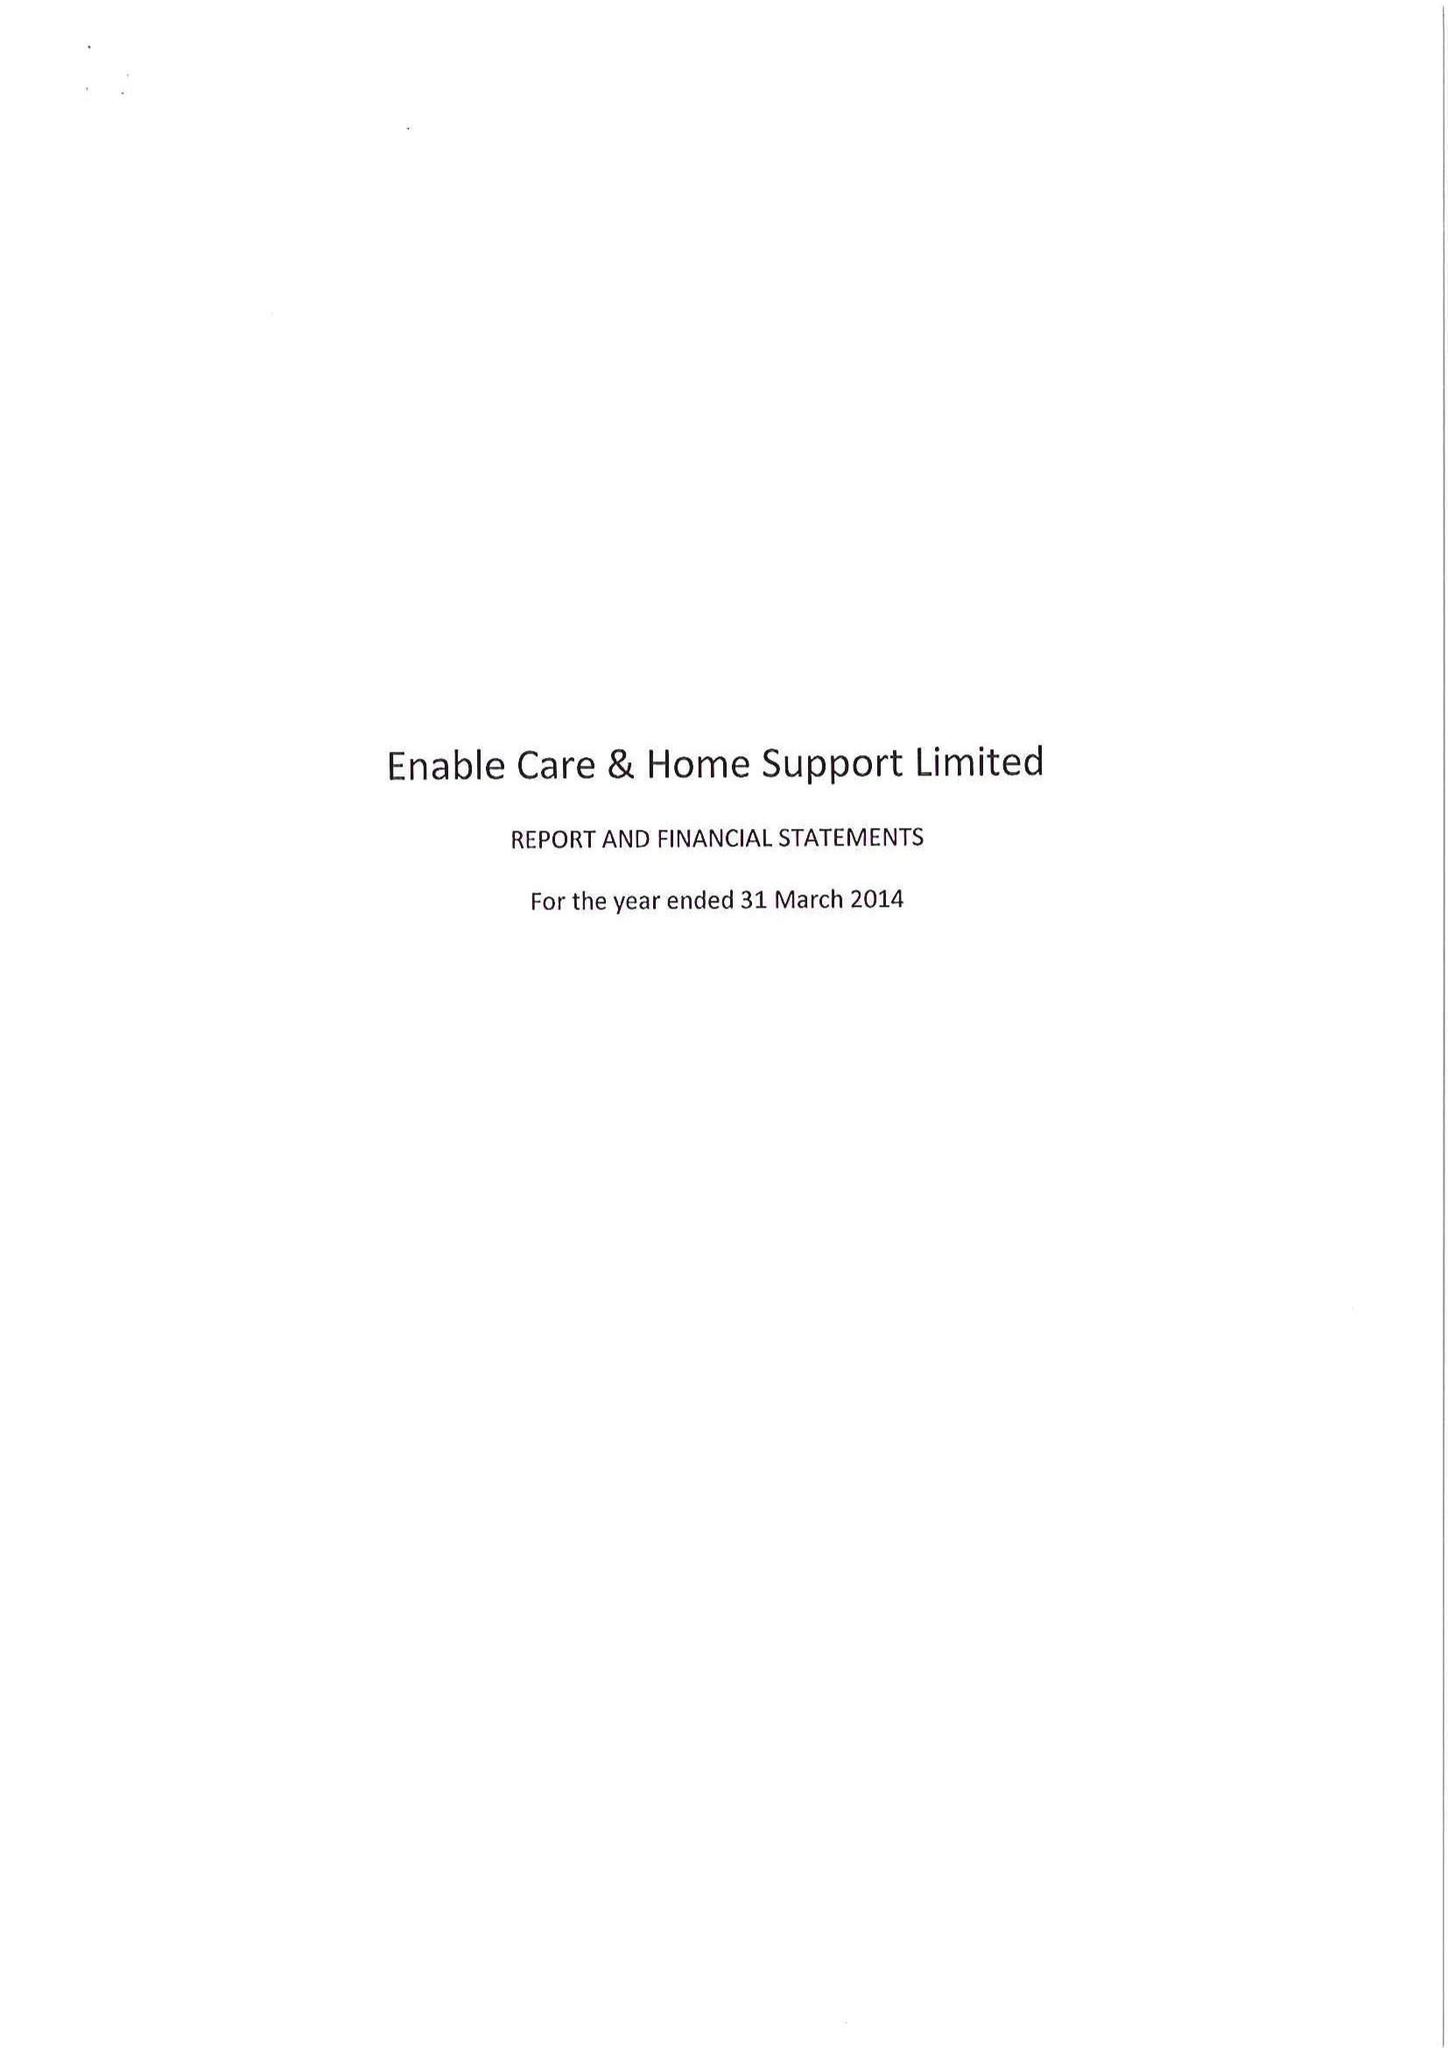What is the value for the charity_name?
Answer the question using a single word or phrase. Enable Care and Home Support Ltd. 